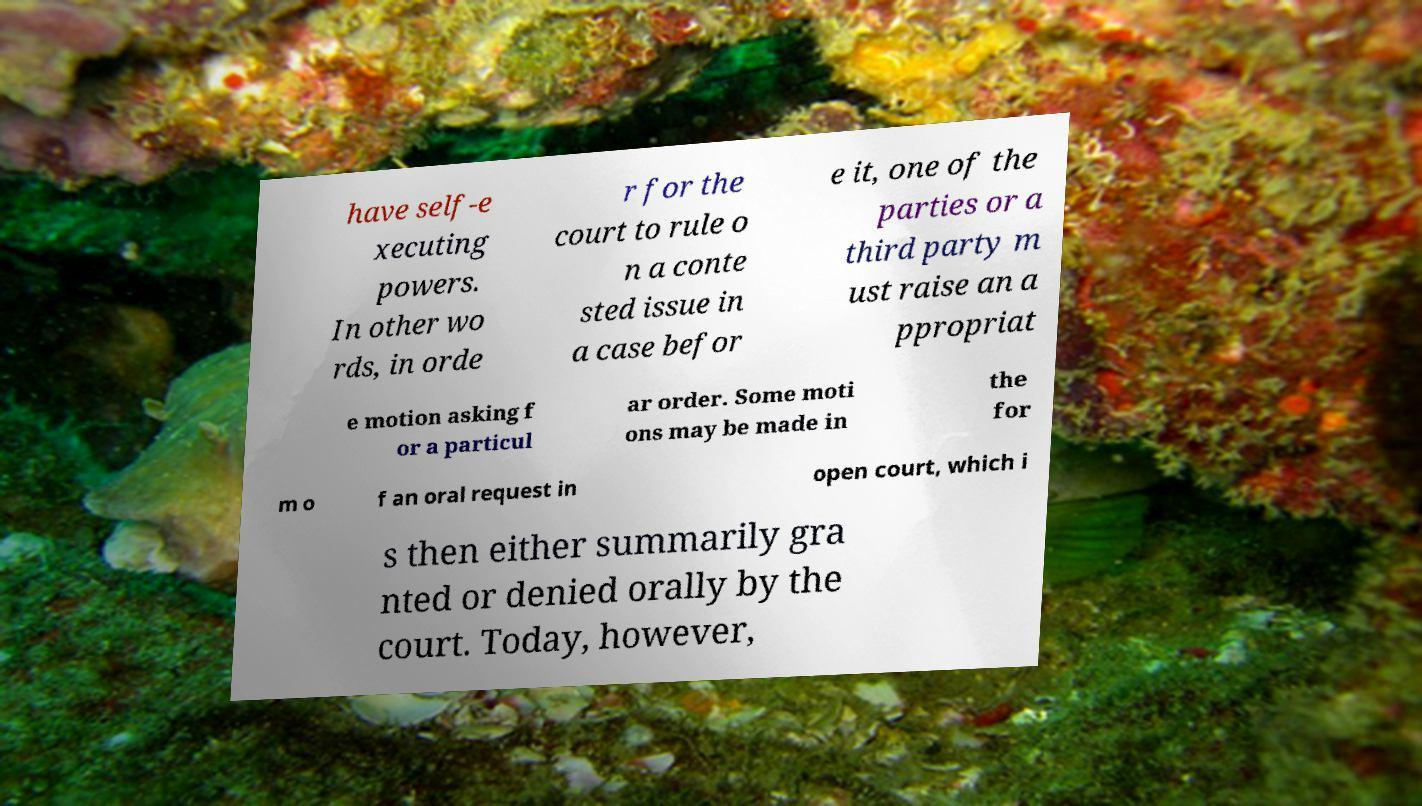Can you accurately transcribe the text from the provided image for me? have self-e xecuting powers. In other wo rds, in orde r for the court to rule o n a conte sted issue in a case befor e it, one of the parties or a third party m ust raise an a ppropriat e motion asking f or a particul ar order. Some moti ons may be made in the for m o f an oral request in open court, which i s then either summarily gra nted or denied orally by the court. Today, however, 